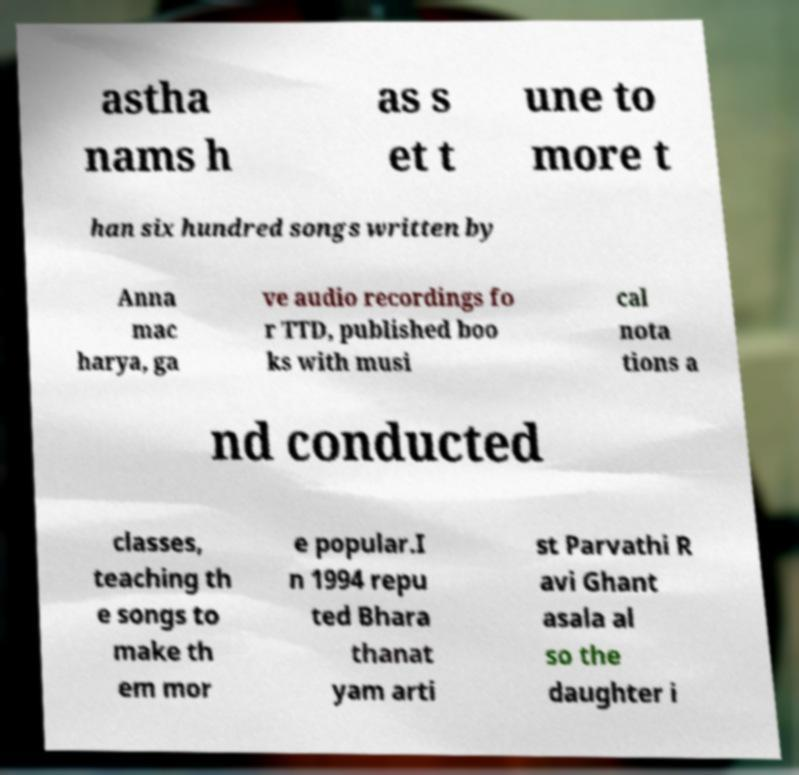Could you assist in decoding the text presented in this image and type it out clearly? astha nams h as s et t une to more t han six hundred songs written by Anna mac harya, ga ve audio recordings fo r TTD, published boo ks with musi cal nota tions a nd conducted classes, teaching th e songs to make th em mor e popular.I n 1994 repu ted Bhara thanat yam arti st Parvathi R avi Ghant asala al so the daughter i 